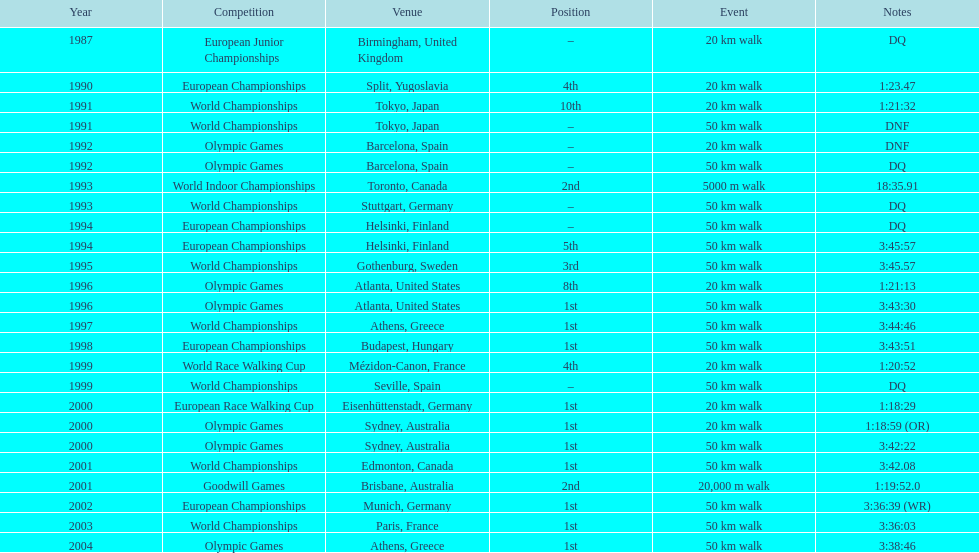How many times did korzeniowski finish higher than fourth place? 13. 